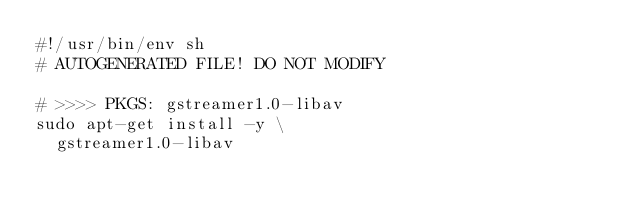Convert code to text. <code><loc_0><loc_0><loc_500><loc_500><_Bash_>#!/usr/bin/env sh
# AUTOGENERATED FILE! DO NOT MODIFY

# >>>> PKGS: gstreamer1.0-libav
sudo apt-get install -y \
	gstreamer1.0-libav
</code> 